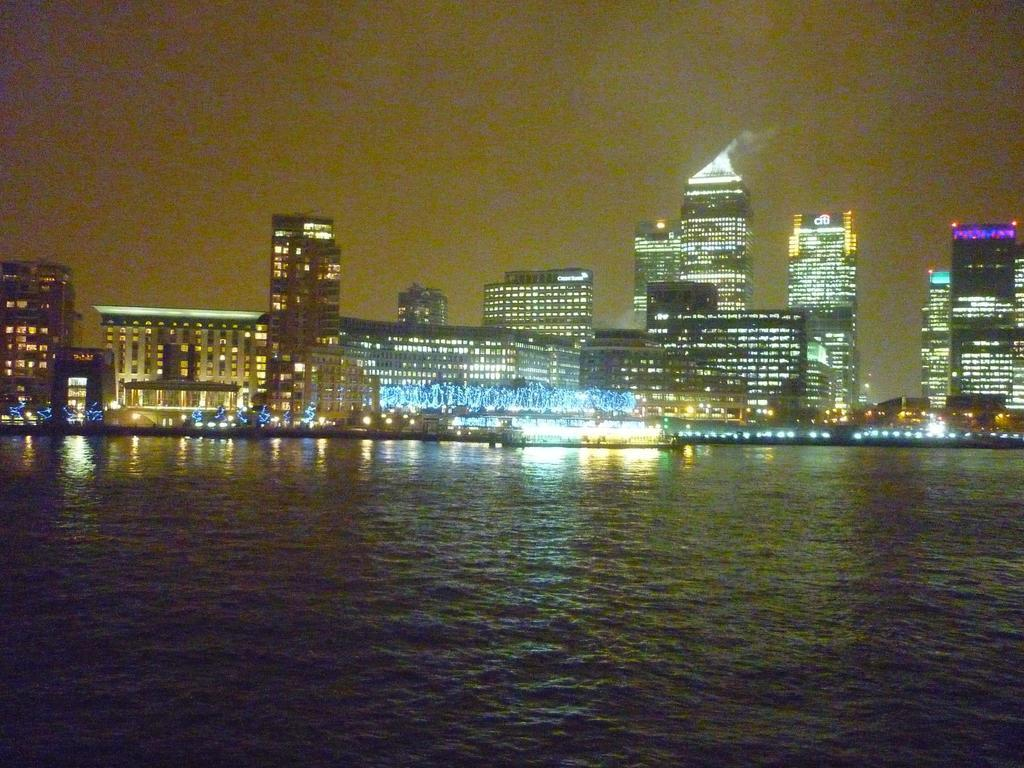What is the lighting condition in the image? The image was taken in the dark. What is located at the bottom of the image? There is a river at the bottom of the image. What can be seen in the background of the image? There are many buildings visible in the background, along with lights. What is visible at the top of the image? The sky is visible at the top of the image. How many pets are visible in the image? There are no pets present in the image. What type of needle is being used to sew the lights in the image? There is no needle visible in the image, as it features a river, buildings, lights, and the sky. 